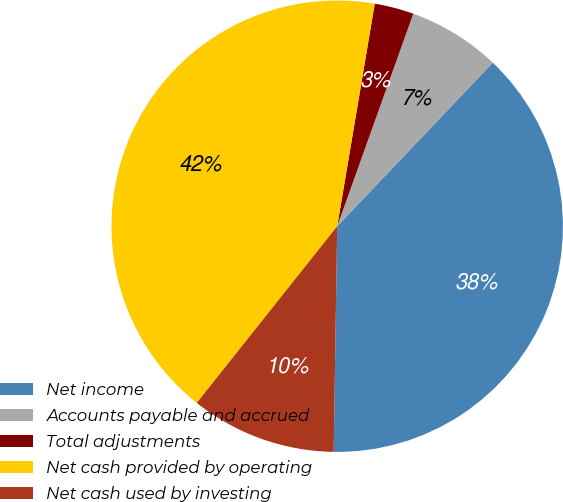Convert chart to OTSL. <chart><loc_0><loc_0><loc_500><loc_500><pie_chart><fcel>Net income<fcel>Accounts payable and accrued<fcel>Total adjustments<fcel>Net cash provided by operating<fcel>Net cash used by investing<nl><fcel>38.15%<fcel>6.63%<fcel>2.81%<fcel>41.97%<fcel>10.44%<nl></chart> 